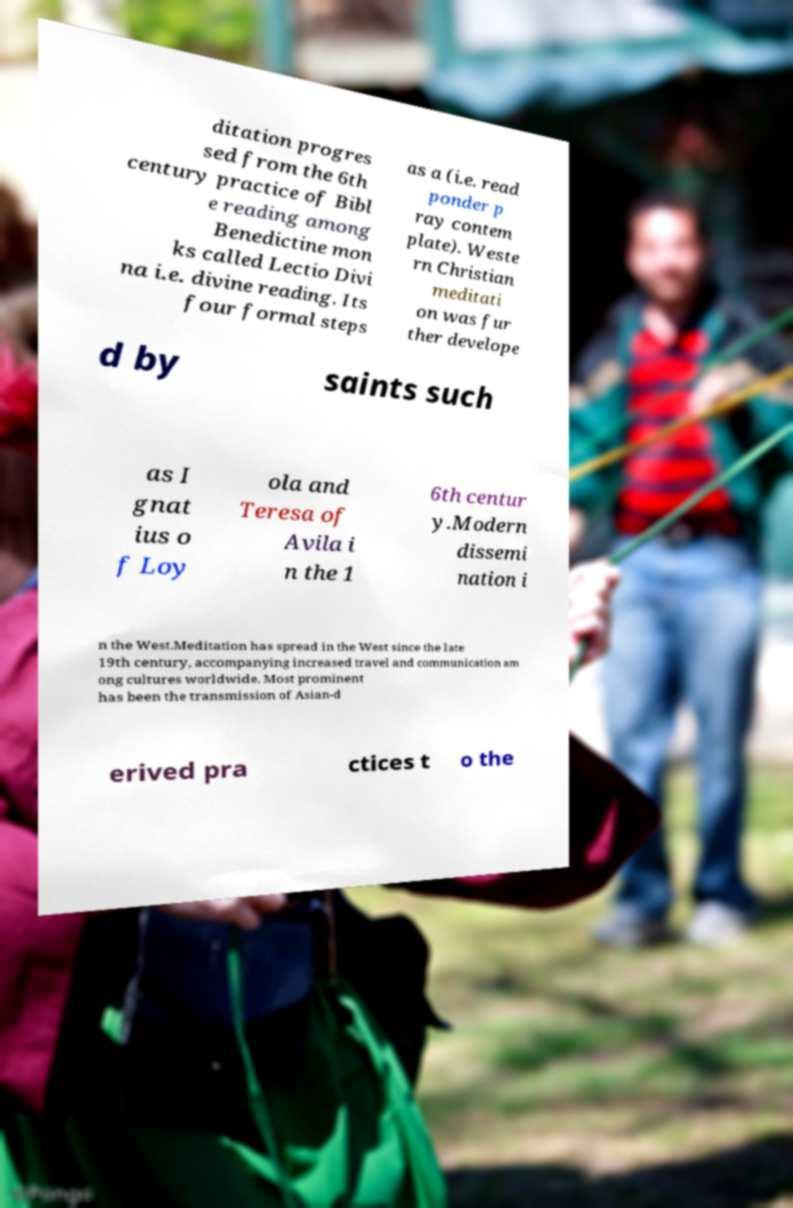I need the written content from this picture converted into text. Can you do that? ditation progres sed from the 6th century practice of Bibl e reading among Benedictine mon ks called Lectio Divi na i.e. divine reading. Its four formal steps as a (i.e. read ponder p ray contem plate). Weste rn Christian meditati on was fur ther develope d by saints such as I gnat ius o f Loy ola and Teresa of Avila i n the 1 6th centur y.Modern dissemi nation i n the West.Meditation has spread in the West since the late 19th century, accompanying increased travel and communication am ong cultures worldwide. Most prominent has been the transmission of Asian-d erived pra ctices t o the 